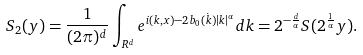<formula> <loc_0><loc_0><loc_500><loc_500>S _ { 2 } ( y ) = \frac { 1 } { ( 2 \pi ) ^ { d } } \int _ { R ^ { d } } e ^ { i ( k , x ) - 2 b _ { 0 } ( \dot { k } ) | k | ^ { \alpha } } d k = 2 ^ { - \frac { d } { \alpha } } S ( 2 ^ { \frac { 1 } { \alpha } } y ) .</formula> 